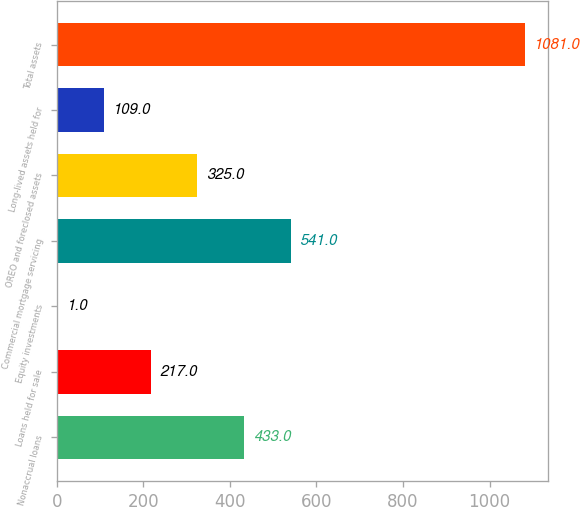Convert chart to OTSL. <chart><loc_0><loc_0><loc_500><loc_500><bar_chart><fcel>Nonaccrual loans<fcel>Loans held for sale<fcel>Equity investments<fcel>Commercial mortgage servicing<fcel>OREO and foreclosed assets<fcel>Long-lived assets held for<fcel>Total assets<nl><fcel>433<fcel>217<fcel>1<fcel>541<fcel>325<fcel>109<fcel>1081<nl></chart> 